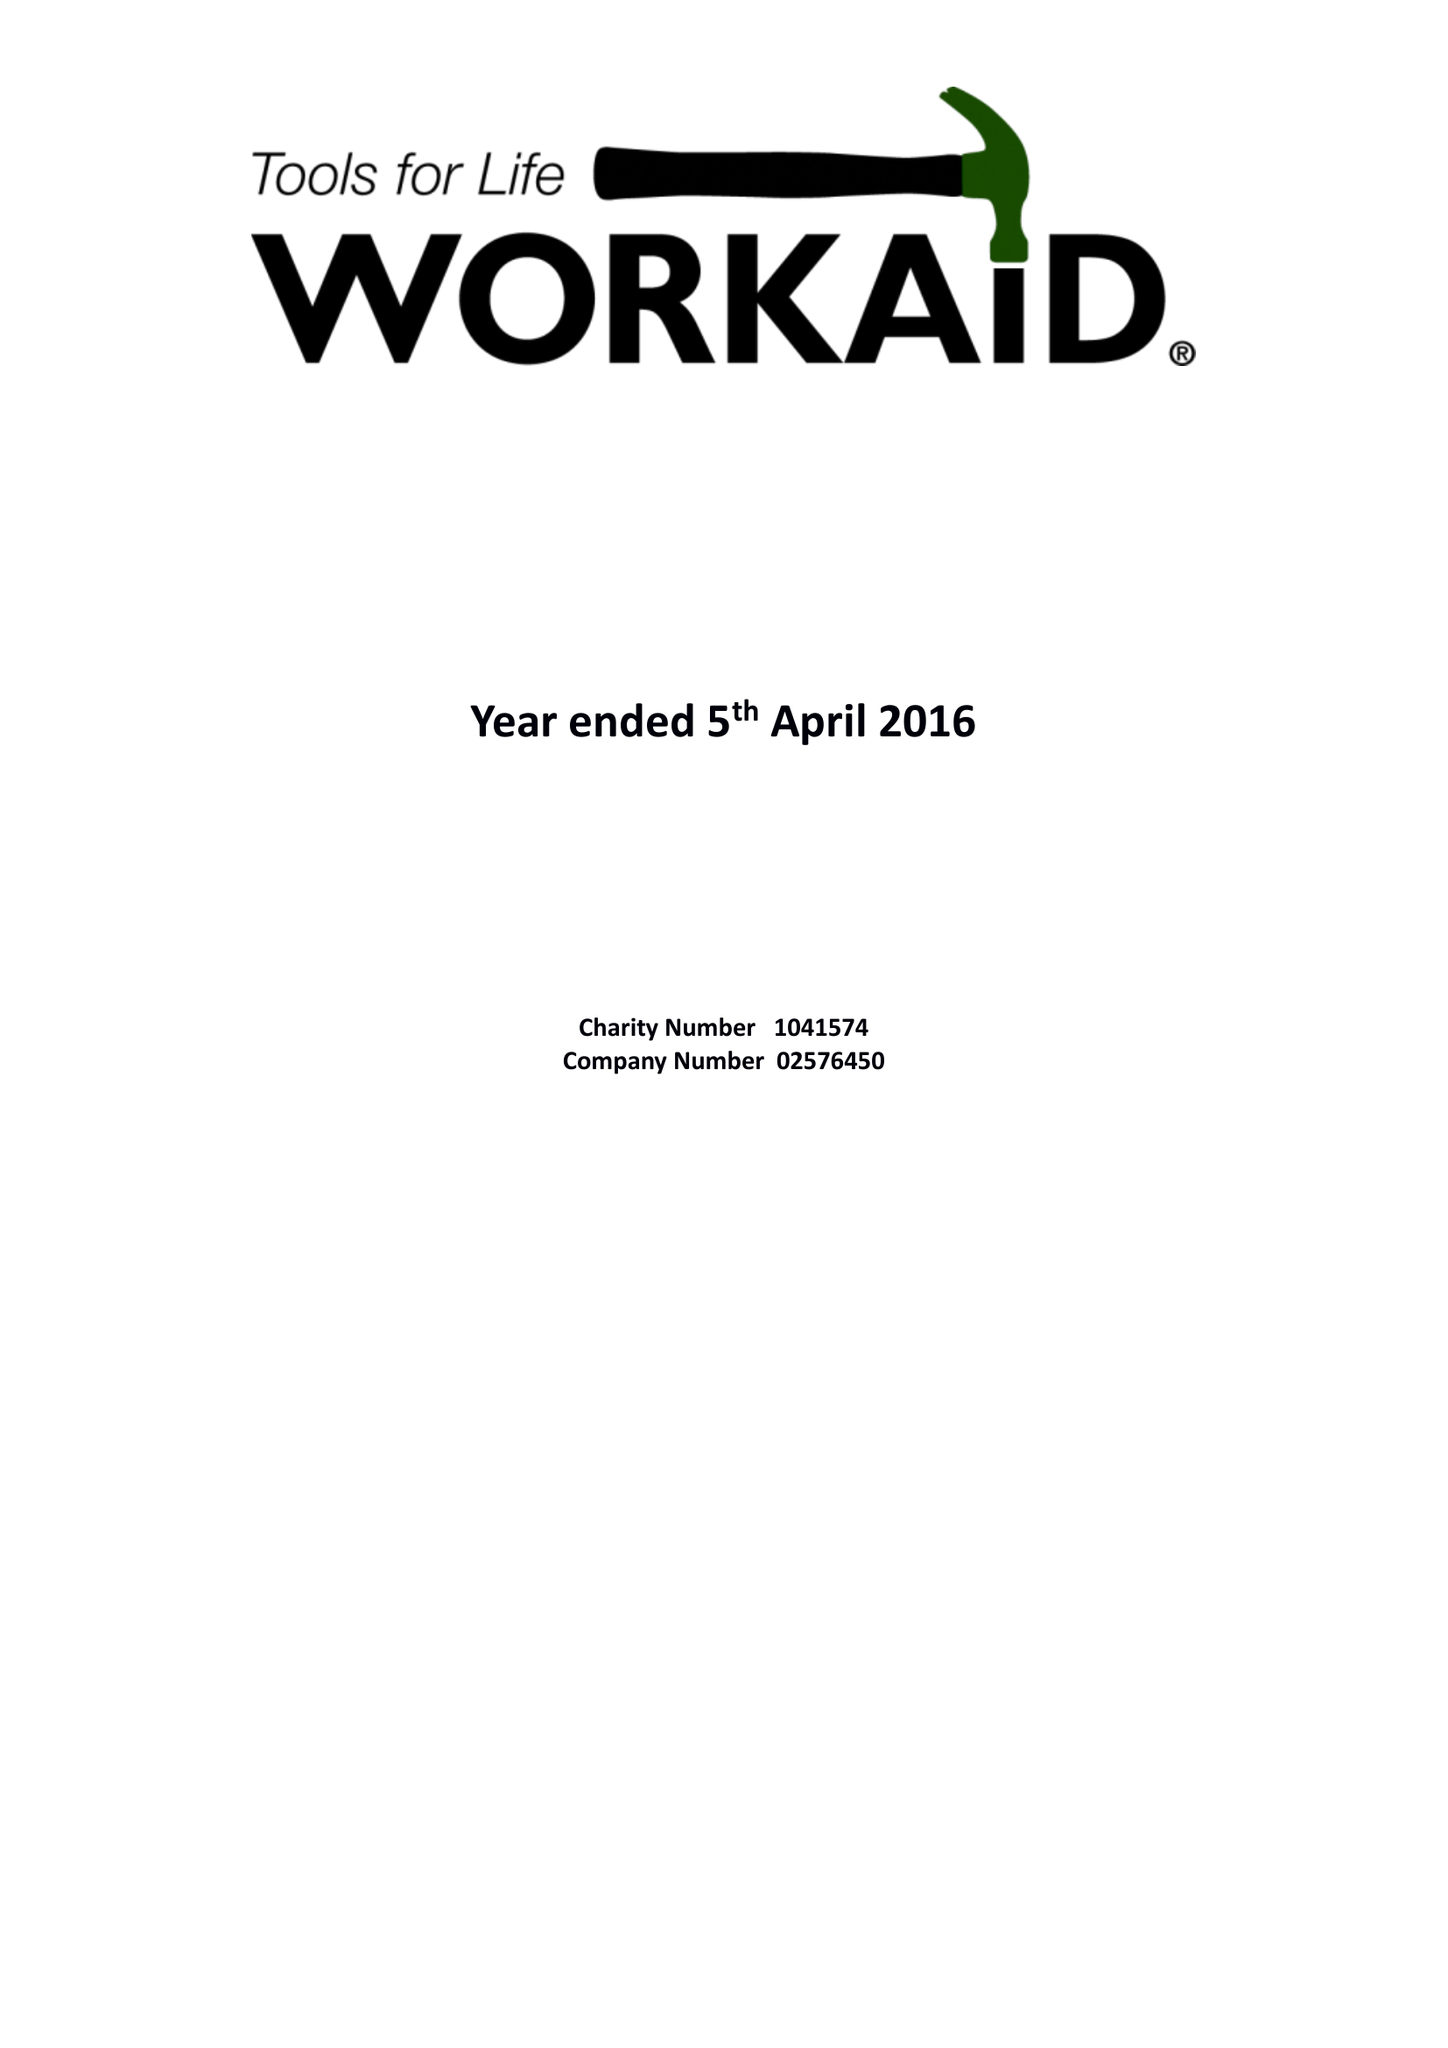What is the value for the address__post_town?
Answer the question using a single word or phrase. CHESHAM 